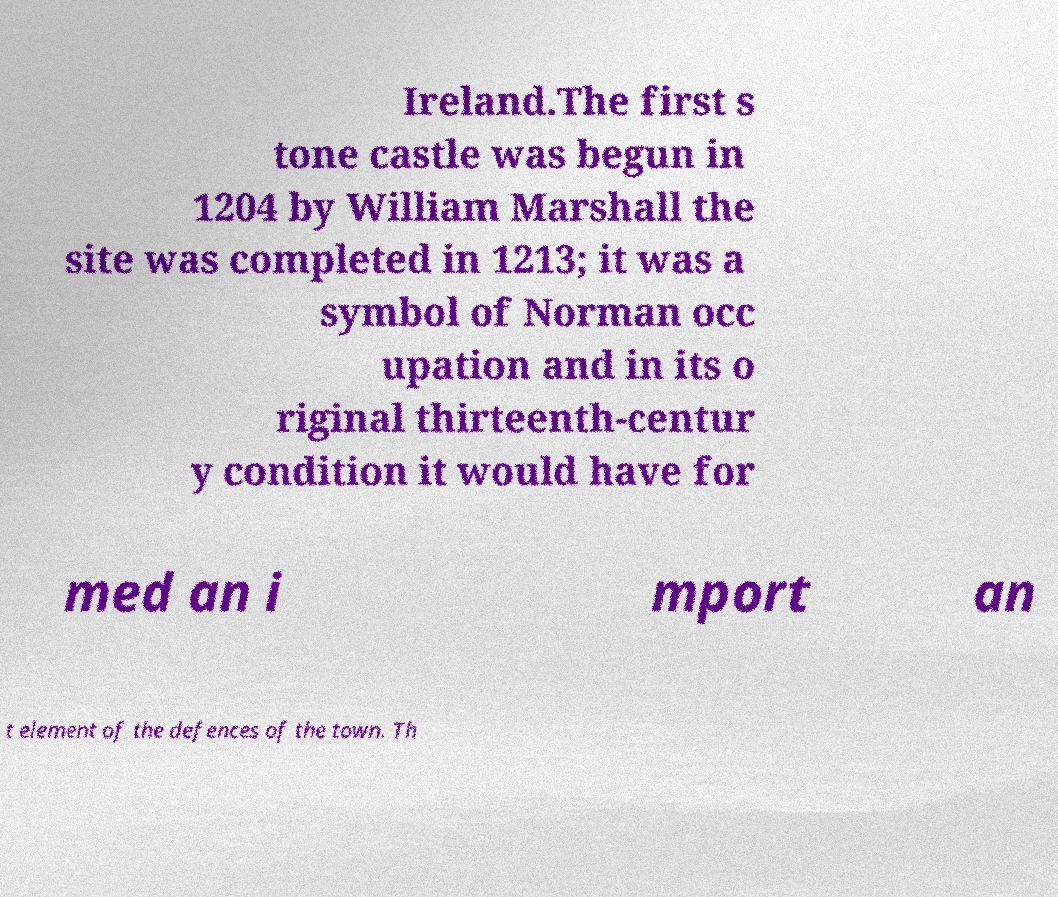I need the written content from this picture converted into text. Can you do that? Ireland.The first s tone castle was begun in 1204 by William Marshall the site was completed in 1213; it was a symbol of Norman occ upation and in its o riginal thirteenth-centur y condition it would have for med an i mport an t element of the defences of the town. Th 